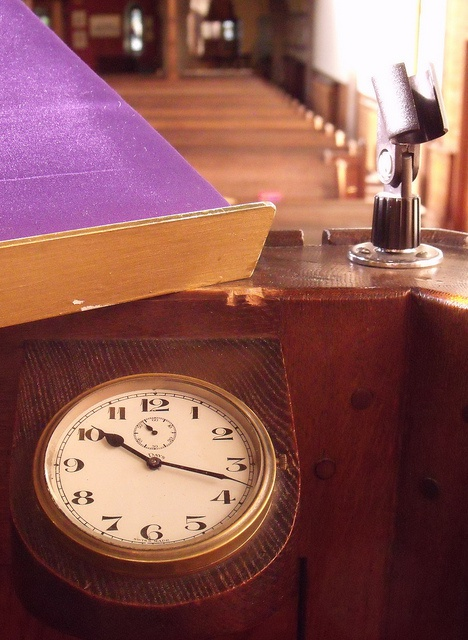Describe the objects in this image and their specific colors. I can see a clock in violet, tan, maroon, and brown tones in this image. 